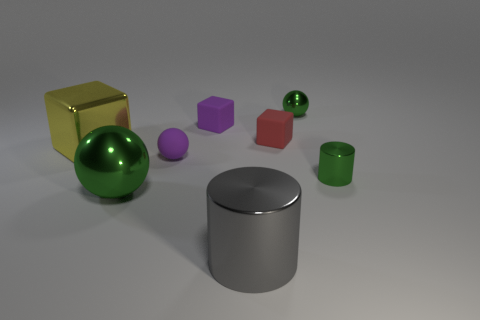Subtract all metal spheres. How many spheres are left? 1 Subtract all yellow blocks. How many blocks are left? 2 Add 2 yellow blocks. How many objects exist? 10 Subtract all gray cylinders. How many green spheres are left? 2 Subtract 2 cubes. How many cubes are left? 1 Subtract all cubes. How many objects are left? 5 Subtract all green matte cubes. Subtract all tiny green cylinders. How many objects are left? 7 Add 1 small cylinders. How many small cylinders are left? 2 Add 1 metal cubes. How many metal cubes exist? 2 Subtract 0 yellow spheres. How many objects are left? 8 